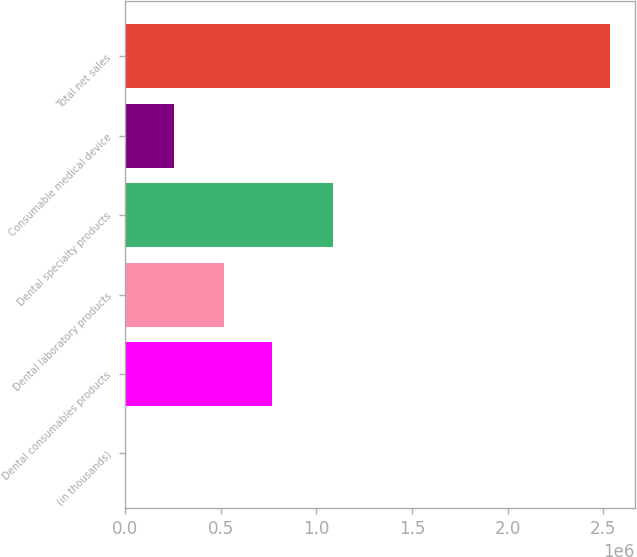Convert chart to OTSL. <chart><loc_0><loc_0><loc_500><loc_500><bar_chart><fcel>(in thousands)<fcel>Dental consumables products<fcel>Dental laboratory products<fcel>Dental specialty products<fcel>Consumable medical device<fcel>Total net sales<nl><fcel>2011<fcel>769062<fcel>515491<fcel>1.08755e+06<fcel>255582<fcel>2.53772e+06<nl></chart> 